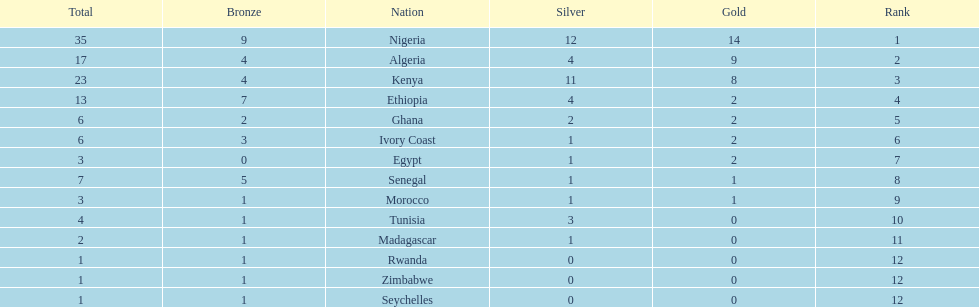Could you parse the entire table as a dict? {'header': ['Total', 'Bronze', 'Nation', 'Silver', 'Gold', 'Rank'], 'rows': [['35', '9', 'Nigeria', '12', '14', '1'], ['17', '4', 'Algeria', '4', '9', '2'], ['23', '4', 'Kenya', '11', '8', '3'], ['13', '7', 'Ethiopia', '4', '2', '4'], ['6', '2', 'Ghana', '2', '2', '5'], ['6', '3', 'Ivory Coast', '1', '2', '6'], ['3', '0', 'Egypt', '1', '2', '7'], ['7', '5', 'Senegal', '1', '1', '8'], ['3', '1', 'Morocco', '1', '1', '9'], ['4', '1', 'Tunisia', '3', '0', '10'], ['2', '1', 'Madagascar', '1', '0', '11'], ['1', '1', 'Rwanda', '0', '0', '12'], ['1', '1', 'Zimbabwe', '0', '0', '12'], ['1', '1', 'Seychelles', '0', '0', '12']]} Which country secured the lowest count of bronze medals? Egypt. 